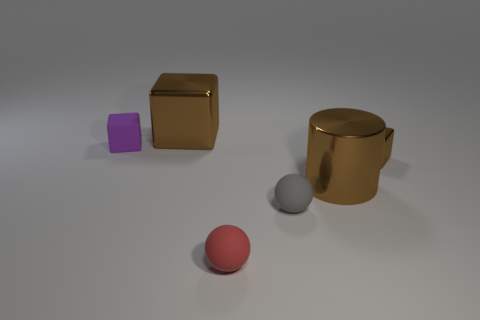Add 1 big blue rubber things. How many objects exist? 7 Subtract all balls. How many objects are left? 4 Subtract 0 green balls. How many objects are left? 6 Subtract all tiny yellow cubes. Subtract all rubber spheres. How many objects are left? 4 Add 5 large cylinders. How many large cylinders are left? 6 Add 2 small red spheres. How many small red spheres exist? 3 